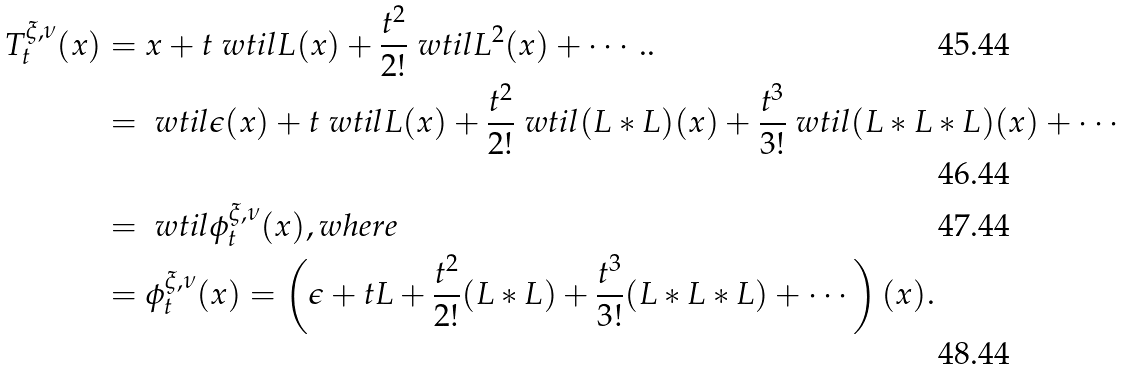<formula> <loc_0><loc_0><loc_500><loc_500>T _ { t } ^ { \xi , \nu } ( x ) & = x + t \ w t i l { L } ( x ) + \frac { t ^ { 2 } } { 2 ! } \ w t i l { L } ^ { 2 } ( x ) + \cdots . . \\ & = \ w t i l { \epsilon } ( x ) + t \ w t i l { L } ( x ) + \frac { t ^ { 2 } } { 2 ! } \ w t i l { ( L \ast L ) } ( x ) + \frac { t ^ { 3 } } { 3 ! } \ w t i l { ( L \ast L \ast L ) } ( x ) + \cdots \\ & = \ w t i l { \phi ^ { \xi , \nu } _ { t } } ( x ) , w h e r e \\ & = \phi _ { t } ^ { \xi , \nu } ( x ) = \left ( \epsilon + t L + \frac { t ^ { 2 } } { 2 ! } ( L \ast L ) + \frac { t ^ { 3 } } { 3 ! } ( L \ast L \ast L ) + \cdots \right ) ( x ) .</formula> 